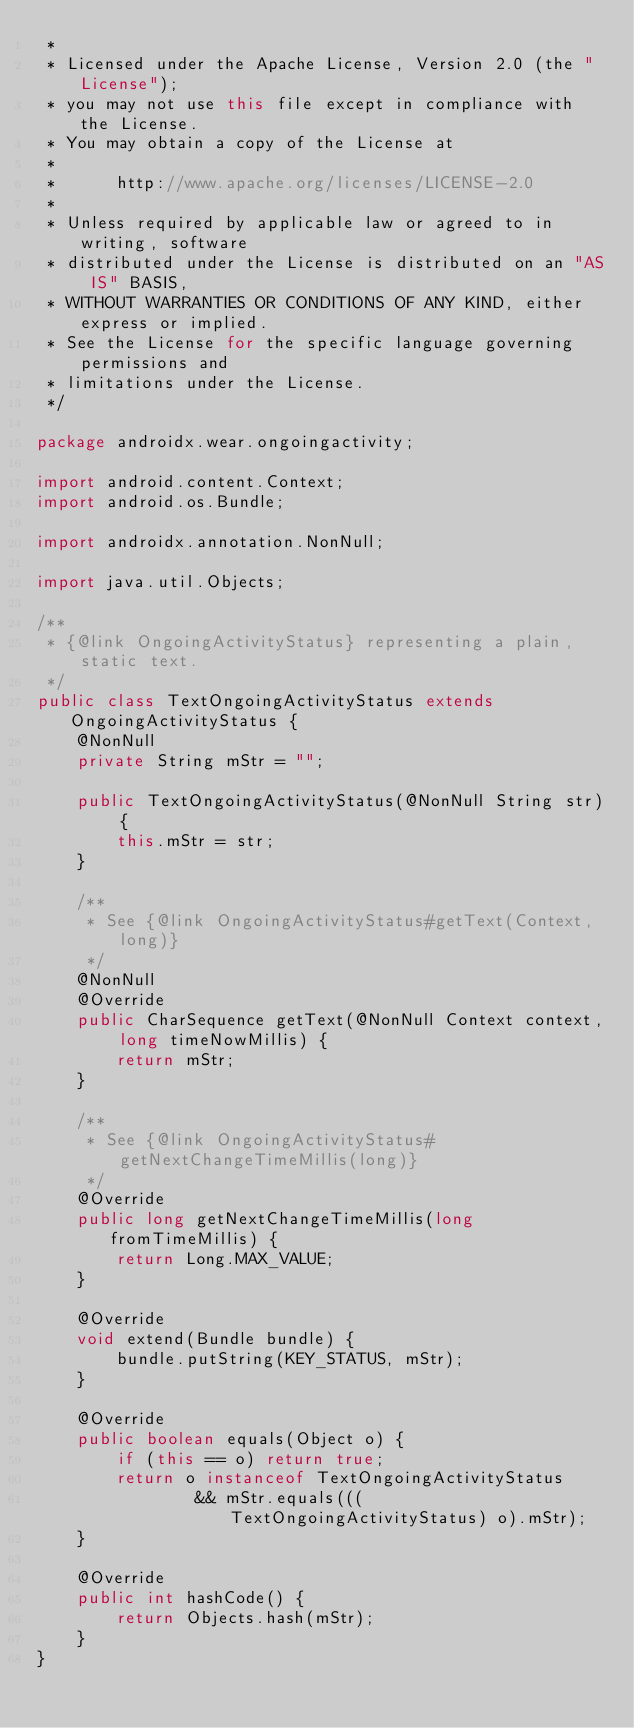<code> <loc_0><loc_0><loc_500><loc_500><_Java_> *
 * Licensed under the Apache License, Version 2.0 (the "License");
 * you may not use this file except in compliance with the License.
 * You may obtain a copy of the License at
 *
 *      http://www.apache.org/licenses/LICENSE-2.0
 *
 * Unless required by applicable law or agreed to in writing, software
 * distributed under the License is distributed on an "AS IS" BASIS,
 * WITHOUT WARRANTIES OR CONDITIONS OF ANY KIND, either express or implied.
 * See the License for the specific language governing permissions and
 * limitations under the License.
 */

package androidx.wear.ongoingactivity;

import android.content.Context;
import android.os.Bundle;

import androidx.annotation.NonNull;

import java.util.Objects;

/**
 * {@link OngoingActivityStatus} representing a plain, static text.
 */
public class TextOngoingActivityStatus extends OngoingActivityStatus {
    @NonNull
    private String mStr = "";

    public TextOngoingActivityStatus(@NonNull String str) {
        this.mStr = str;
    }

    /**
     * See {@link OngoingActivityStatus#getText(Context, long)}
     */
    @NonNull
    @Override
    public CharSequence getText(@NonNull Context context, long timeNowMillis) {
        return mStr;
    }

    /**
     * See {@link OngoingActivityStatus#getNextChangeTimeMillis(long)}
     */
    @Override
    public long getNextChangeTimeMillis(long fromTimeMillis) {
        return Long.MAX_VALUE;
    }

    @Override
    void extend(Bundle bundle) {
        bundle.putString(KEY_STATUS, mStr);
    }

    @Override
    public boolean equals(Object o) {
        if (this == o) return true;
        return o instanceof TextOngoingActivityStatus
                && mStr.equals(((TextOngoingActivityStatus) o).mStr);
    }

    @Override
    public int hashCode() {
        return Objects.hash(mStr);
    }
}
</code> 